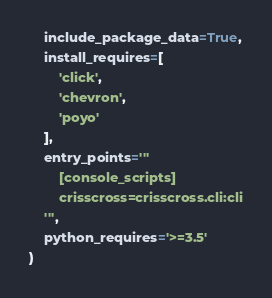<code> <loc_0><loc_0><loc_500><loc_500><_Python_>    include_package_data=True,
    install_requires=[
        'click',
        'chevron',
        'poyo'
    ],
    entry_points='''
        [console_scripts]
        crisscross=crisscross.cli:cli
    ''',
    python_requires='>=3.5'
)
</code> 